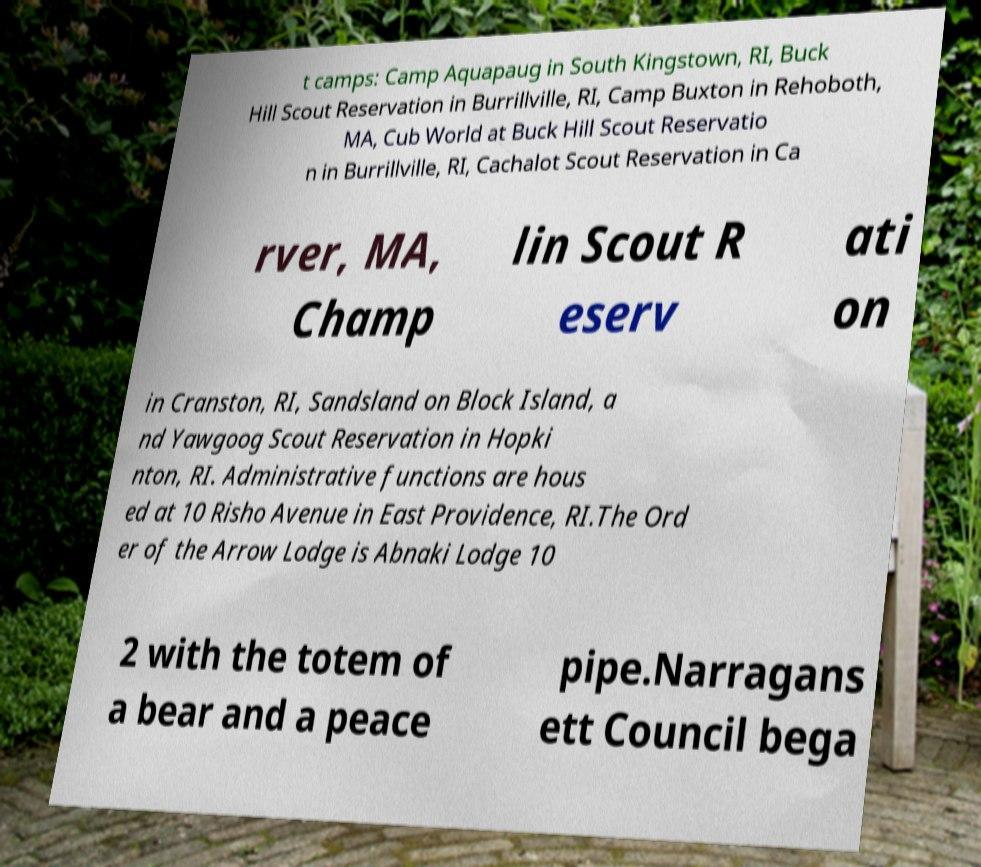Please read and relay the text visible in this image. What does it say? t camps: Camp Aquapaug in South Kingstown, RI, Buck Hill Scout Reservation in Burrillville, RI, Camp Buxton in Rehoboth, MA, Cub World at Buck Hill Scout Reservatio n in Burrillville, RI, Cachalot Scout Reservation in Ca rver, MA, Champ lin Scout R eserv ati on in Cranston, RI, Sandsland on Block Island, a nd Yawgoog Scout Reservation in Hopki nton, RI. Administrative functions are hous ed at 10 Risho Avenue in East Providence, RI.The Ord er of the Arrow Lodge is Abnaki Lodge 10 2 with the totem of a bear and a peace pipe.Narragans ett Council bega 